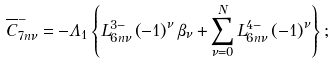<formula> <loc_0><loc_0><loc_500><loc_500>\overline { C } _ { 7 n \nu } ^ { - } = - \Lambda _ { 1 } \left \{ L _ { 6 n \nu } ^ { 3 - } \left ( - 1 \right ) ^ { \nu } \beta _ { \nu } + \sum _ { \nu = 0 } ^ { N } L _ { 6 n \nu } ^ { 4 - } \left ( - 1 \right ) ^ { \nu } \right \} ;</formula> 